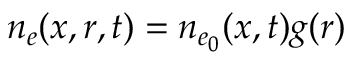<formula> <loc_0><loc_0><loc_500><loc_500>n _ { e } ( x , r , t ) = n _ { e _ { 0 } } ( x , t ) g ( r )</formula> 